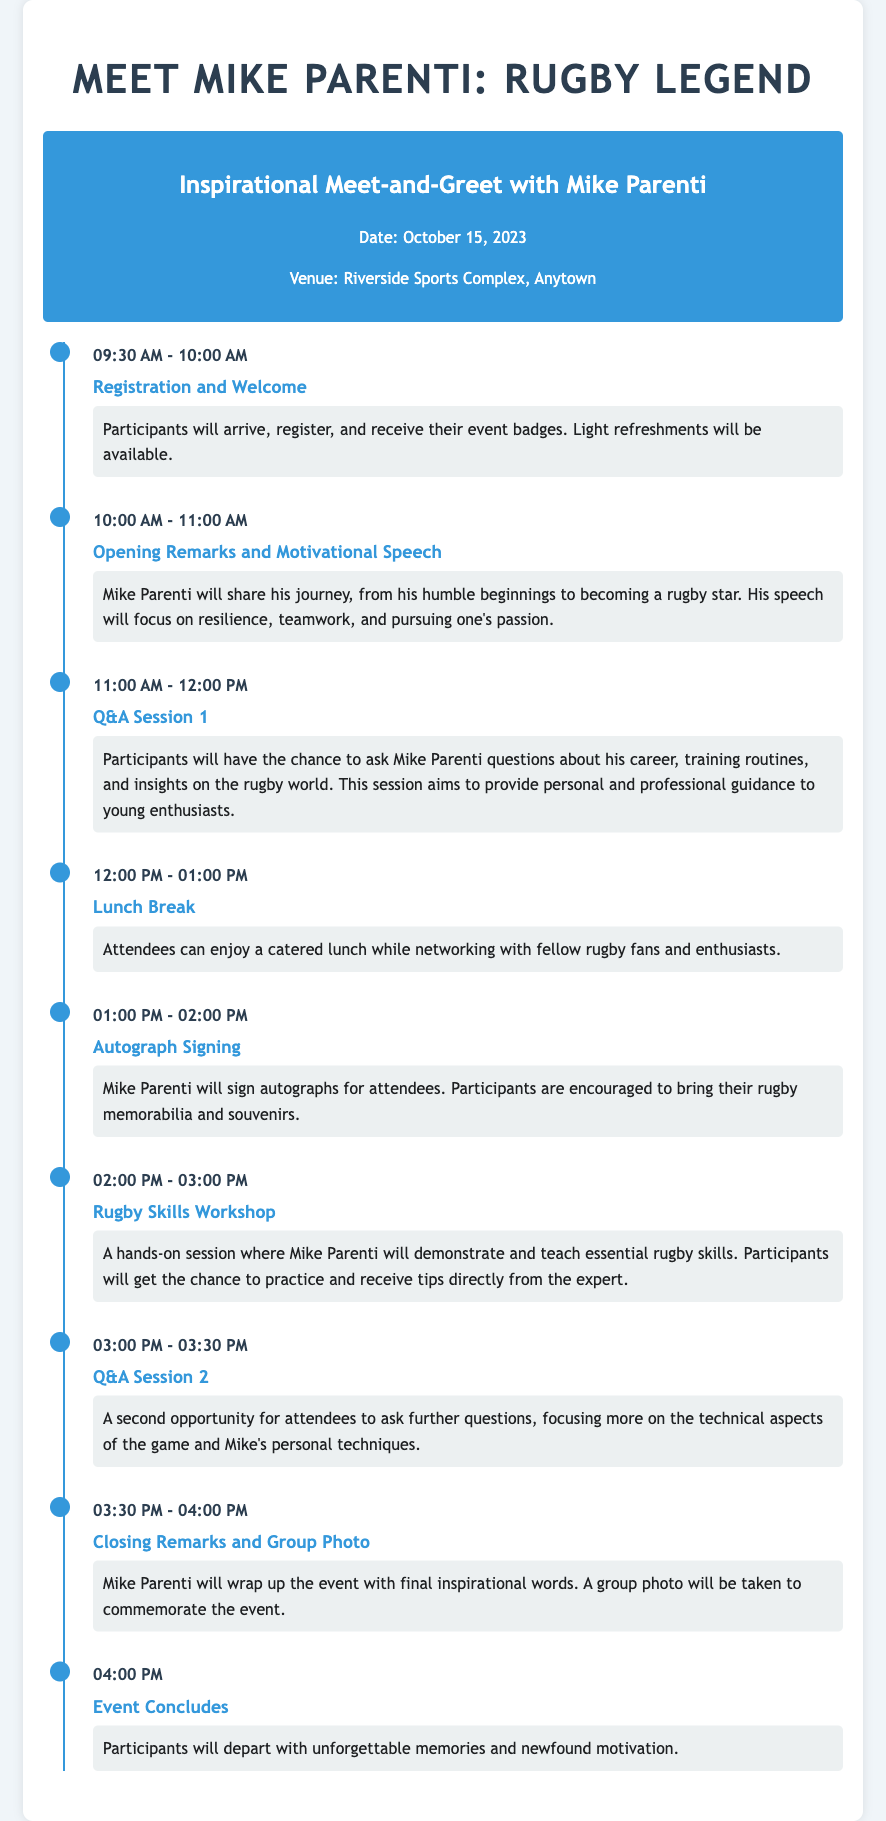What is the date of the event? The date of the event is specified in the document as October 15, 2023.
Answer: October 15, 2023 What time does the registration start? According to the timeline, registration begins at 09:30 AM.
Answer: 09:30 AM Who will be sharing the motivational speech? The document states that Mike Parenti will deliver the motivational speech.
Answer: Mike Parenti How long is the lunch break? The itinerary indicates that the lunch break lasts for one hour, from 12:00 PM to 01:00 PM.
Answer: One hour What activity follows the autograph signing? After the autograph signing, participants will attend a Rugby Skills Workshop.
Answer: Rugby Skills Workshop When does the second Q&A session occur? The second Q&A session is scheduled for 03:00 PM.
Answer: 03:00 PM What style of questions will be encouraged in the Q&A sessions? The document emphasizes that questions will focus on Mike's career, training routines, and insights into rugby.
Answer: Career, training routines, insights into rugby Is there a group photo at the event? Yes, the itinerary mentions that a group photo will be taken during the closing remarks.
Answer: Yes 